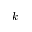<formula> <loc_0><loc_0><loc_500><loc_500>k</formula> 